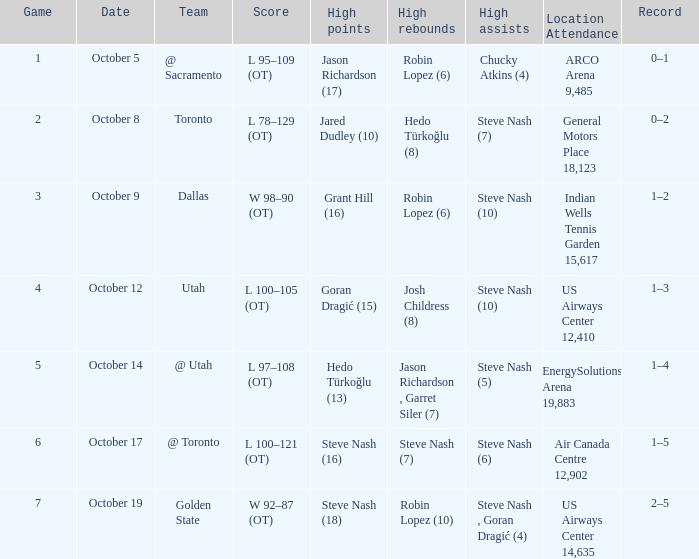What was the maximum number of rebounds robin lopez (10) recorded in a single game? 1.0. 